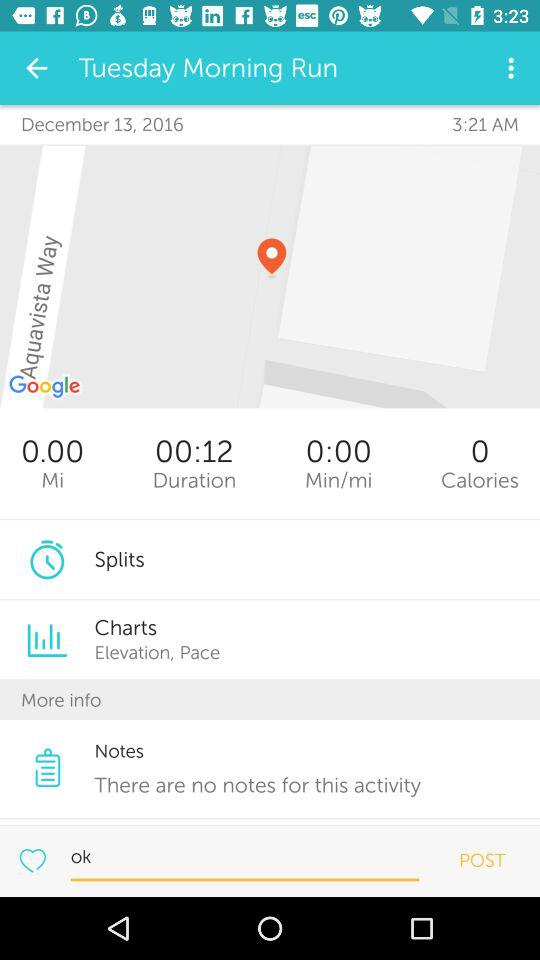What is the selected date for the Morning Run? The selected date is December 13, 2016. 